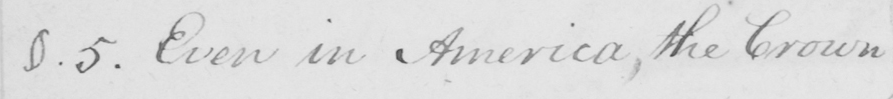What does this handwritten line say? §.5 . Even in America , the Crown 